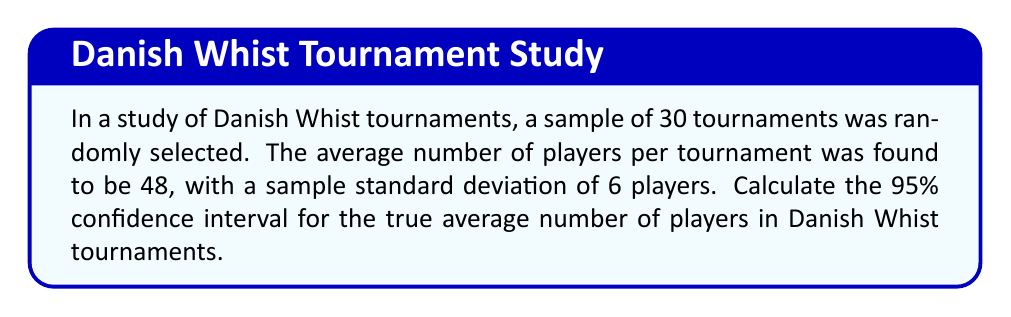Teach me how to tackle this problem. To calculate the confidence interval, we'll follow these steps:

1. Identify the given information:
   - Sample size: $n = 30$
   - Sample mean: $\bar{x} = 48$
   - Sample standard deviation: $s = 6$
   - Confidence level: 95%

2. Determine the critical value:
   For a 95% confidence interval with $n = 30$ (df = 29), we use the t-distribution.
   The critical value is $t_{0.025, 29} = 2.045$ (from t-table)

3. Calculate the standard error of the mean:
   $SE = \frac{s}{\sqrt{n}} = \frac{6}{\sqrt{30}} = 1.095$

4. Calculate the margin of error:
   $ME = t_{0.025, 29} \times SE = 2.045 \times 1.095 = 2.239$

5. Compute the confidence interval:
   Lower bound: $\bar{x} - ME = 48 - 2.239 = 45.761$
   Upper bound: $\bar{x} + ME = 48 + 2.239 = 50.239$

Therefore, the 95% confidence interval is (45.761, 50.239).
Answer: (45.761, 50.239) 